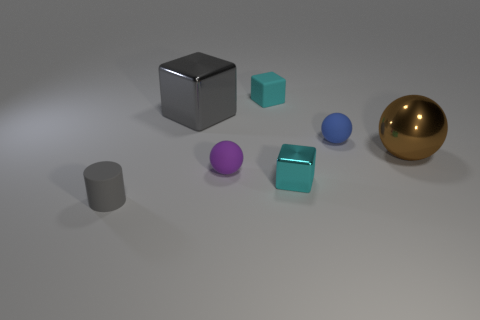What shape is the tiny object that is both on the right side of the tiny matte block and in front of the tiny blue thing? cube 